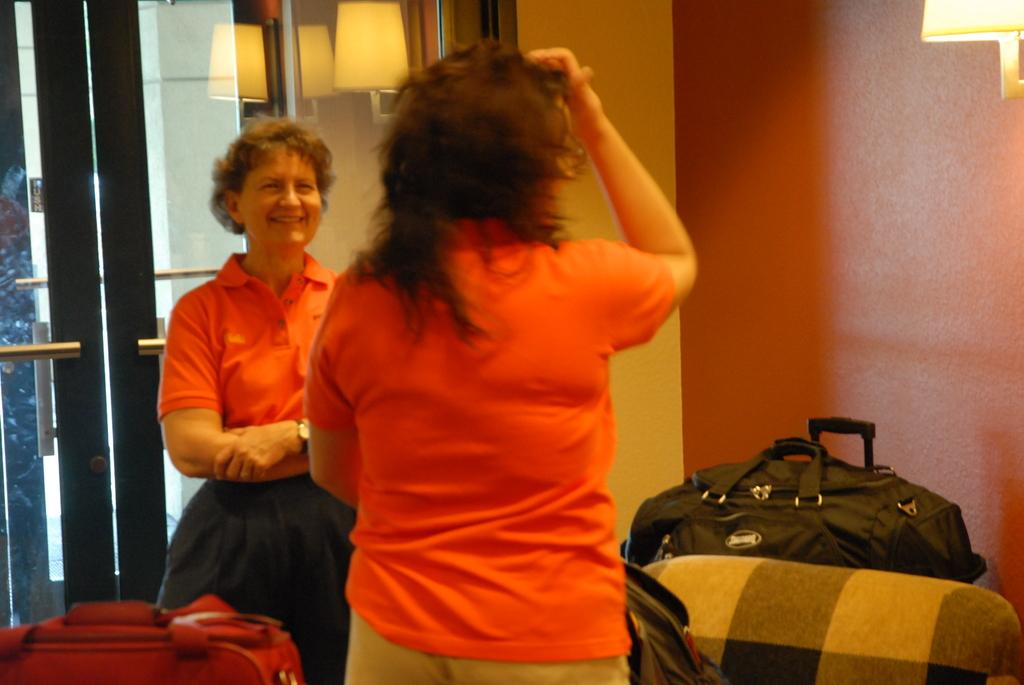How many women are in the image? There are two women in the image. Can you describe the facial expression of one of the women? One of the women is smiling. What else can be seen in the image besides the women? Baggage is visible in the image. What architectural features can be seen in the background of the image? There are doors and a light in the background of the image. Where is the friend sitting on the throne in the image? There is no friend or throne present in the image. 